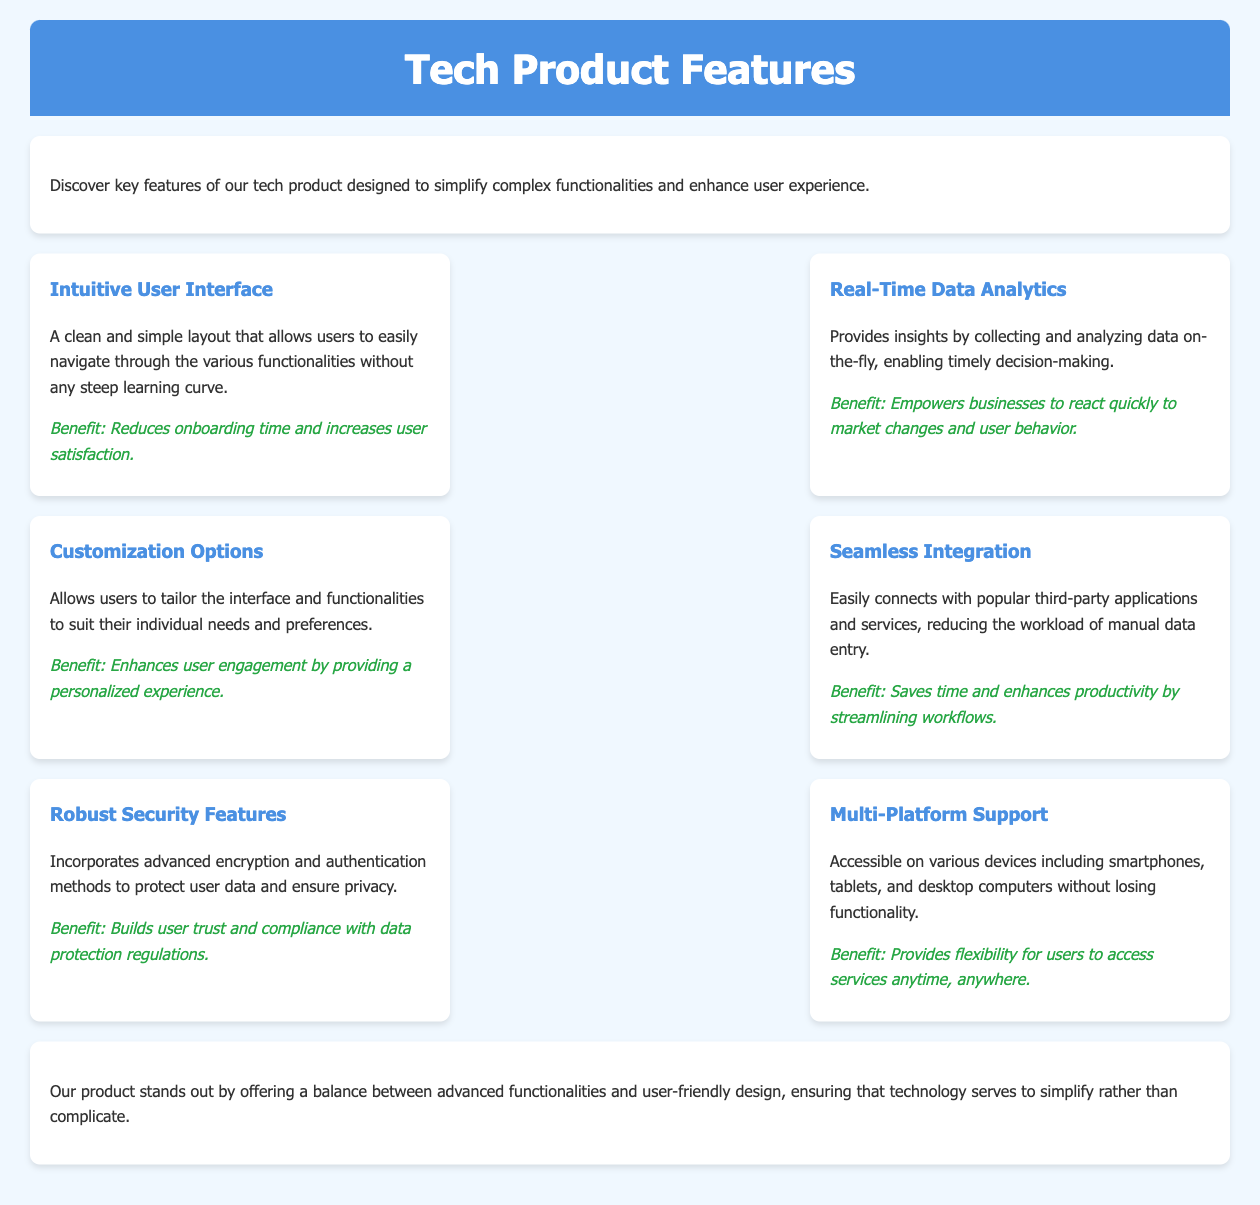what is the title of the document? The title of the document is found in the header section, which describes the overarching theme or content of the document.
Answer: Tech Product Features how many key features are listed in the document? The document details the number of features presented in the features section.
Answer: Six what are the main benefits of the Intuitive User Interface? The benefit of this feature is stated in the description immediately following it.
Answer: Reduces onboarding time and increases user satisfaction which feature emphasizes customization? This feature allows users to tailor their experience according to individual preferences.
Answer: Customization Options what does the Robust Security Features focus on? The focus of this feature is explained in the feature description specifically.
Answer: Protect user data and ensure privacy how does Multi-Platform Support benefit users? The benefit of this feature is mentioned to explain its advantage to users.
Answer: Provides flexibility for users to access services anytime, anywhere what unique function does Real-Time Data Analytics offer? The unique function is described in the feature's explanation about its capabilities.
Answer: Provides insights by collecting and analyzing data on-the-fly what is the theme of the conclusion? The conclusion summarizes the overall objective and effectiveness of the product features.
Answer: Balance between advanced functionalities and user-friendly design 